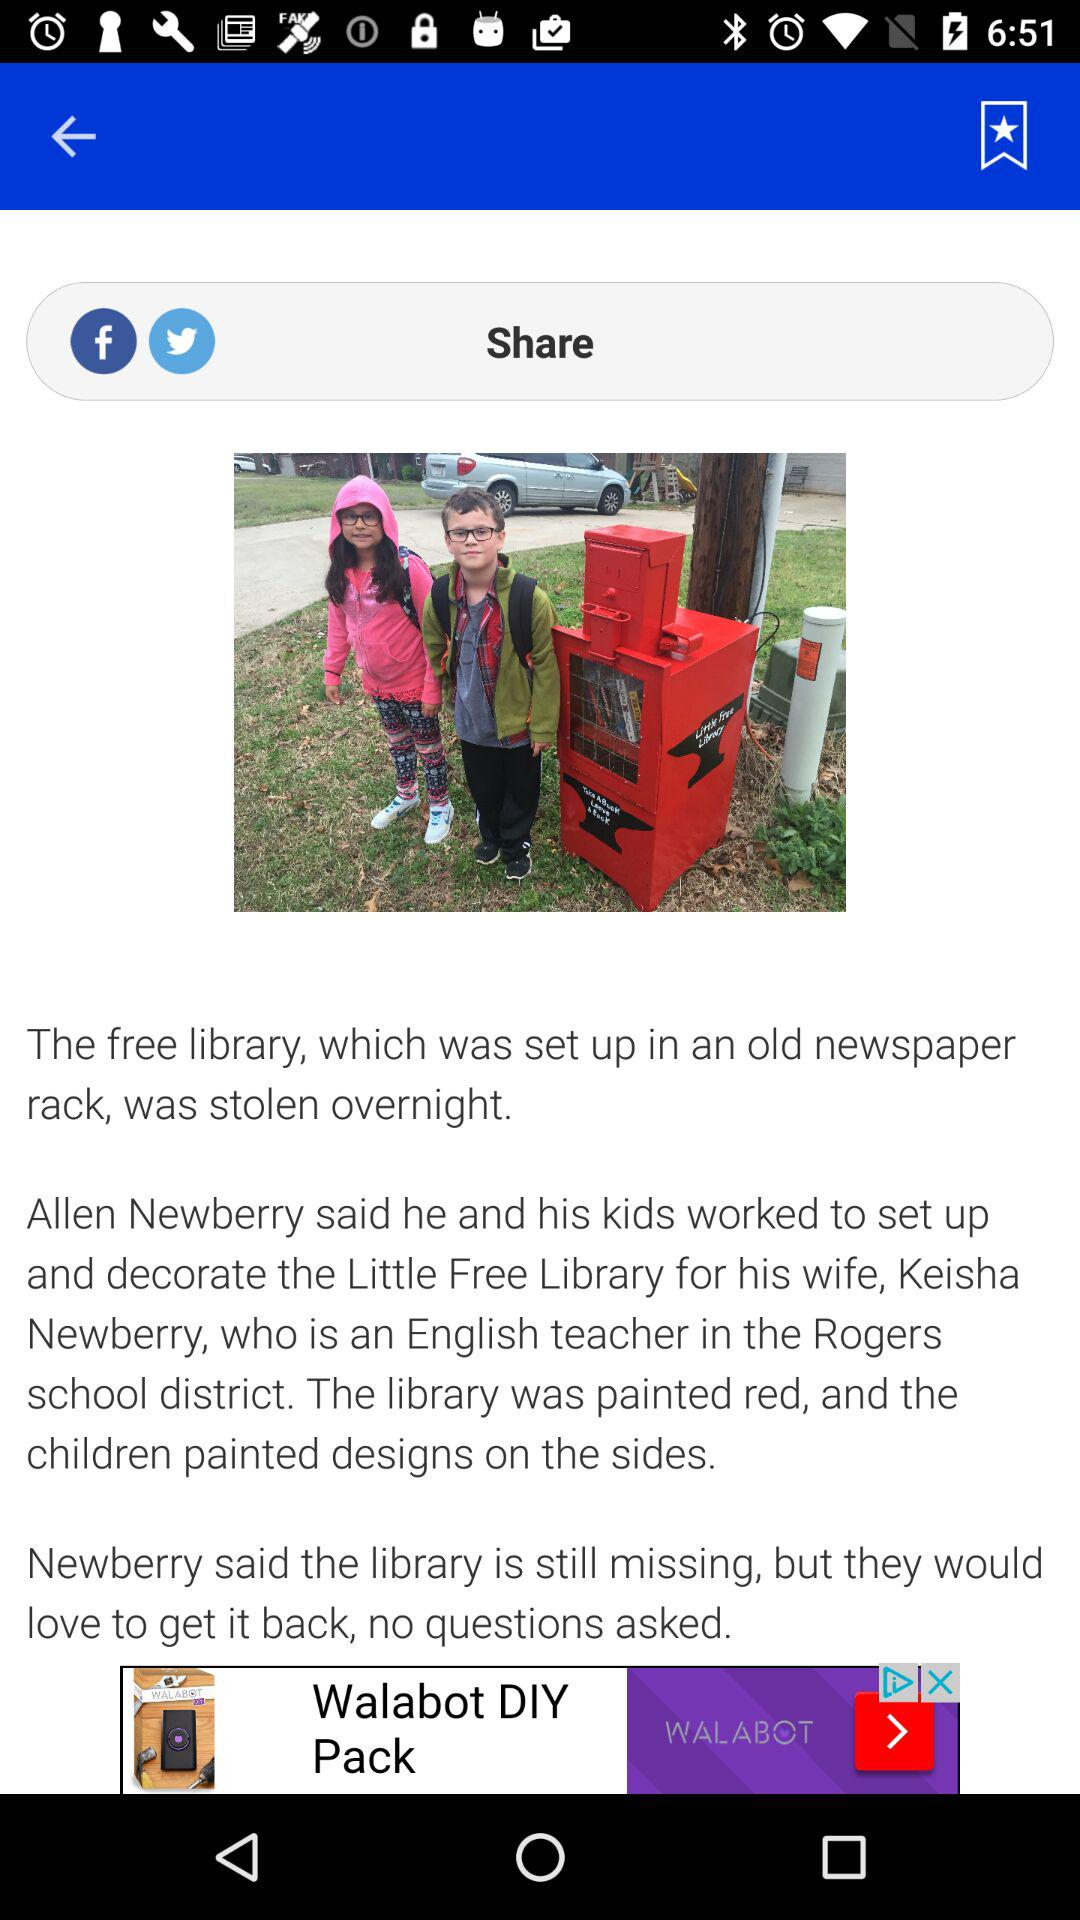What school district is Keisha Newberry from? Keisha Newberry is from the Rogers school district. 